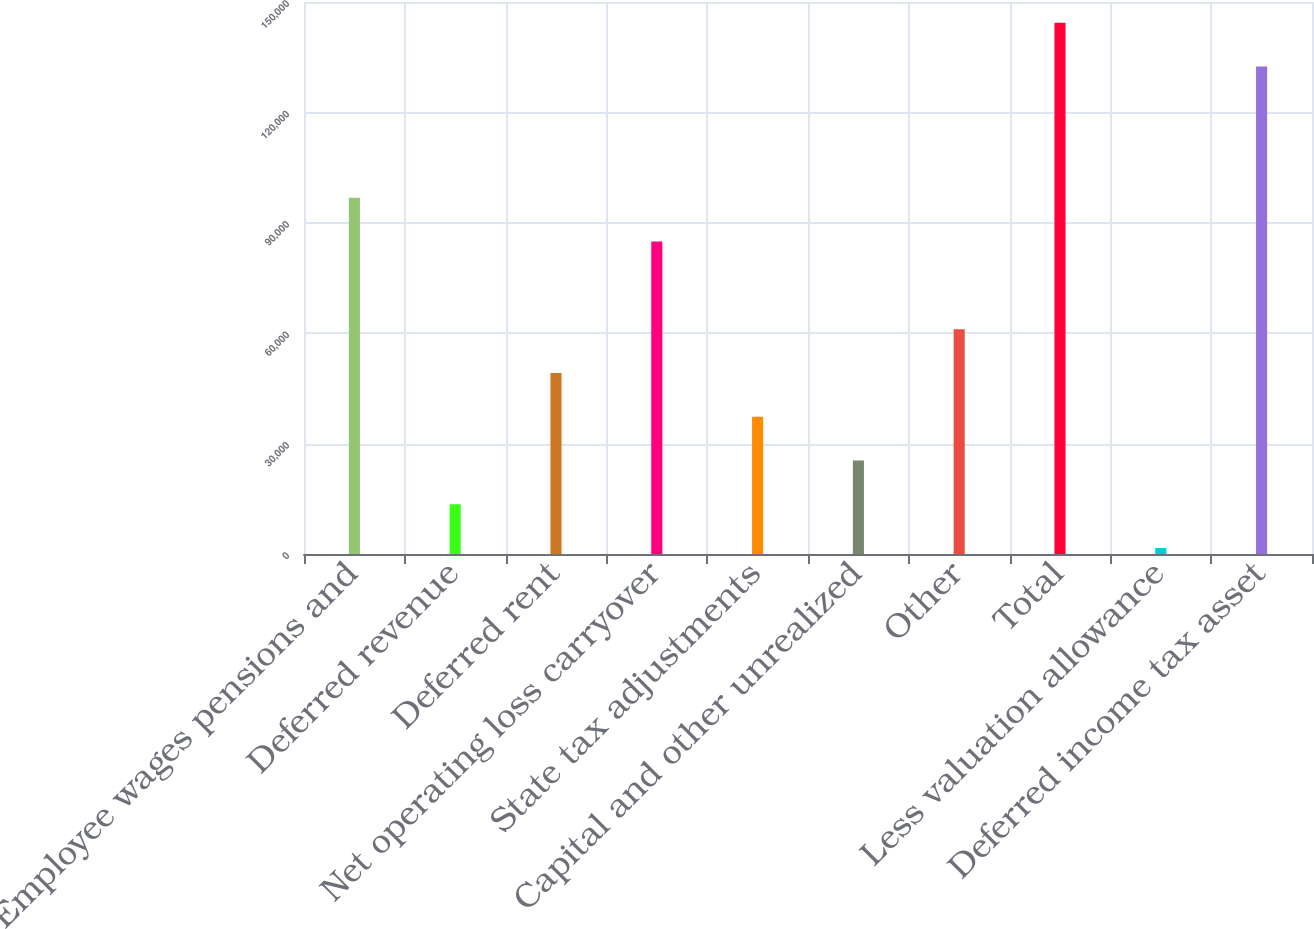Convert chart. <chart><loc_0><loc_0><loc_500><loc_500><bar_chart><fcel>Employee wages pensions and<fcel>Deferred revenue<fcel>Deferred rent<fcel>Net operating loss carryover<fcel>State tax adjustments<fcel>Capital and other unrealized<fcel>Other<fcel>Total<fcel>Less valuation allowance<fcel>Deferred income tax asset<nl><fcel>96788.6<fcel>13511.7<fcel>49201.8<fcel>84891.9<fcel>37305.1<fcel>25408.4<fcel>61098.5<fcel>144375<fcel>1615<fcel>132479<nl></chart> 